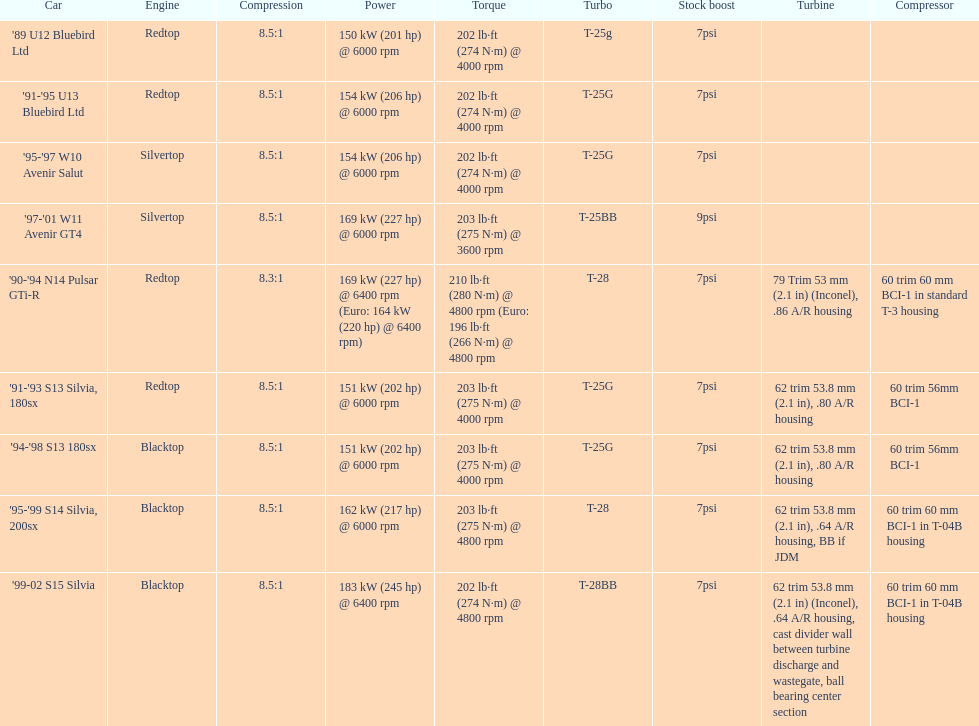Which car has a stock boost of over 7psi? '97-'01 W11 Avenir GT4. 